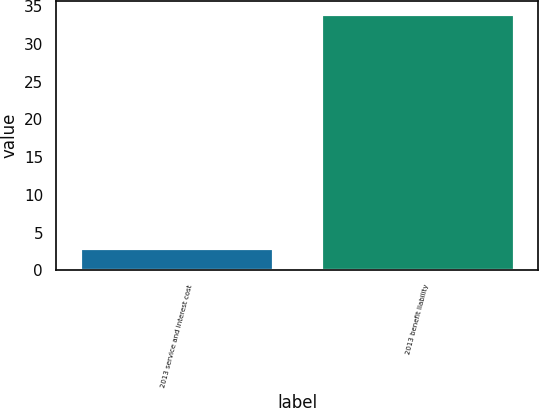Convert chart. <chart><loc_0><loc_0><loc_500><loc_500><bar_chart><fcel>2013 service and interest cost<fcel>2013 benefit liability<nl><fcel>3<fcel>34<nl></chart> 